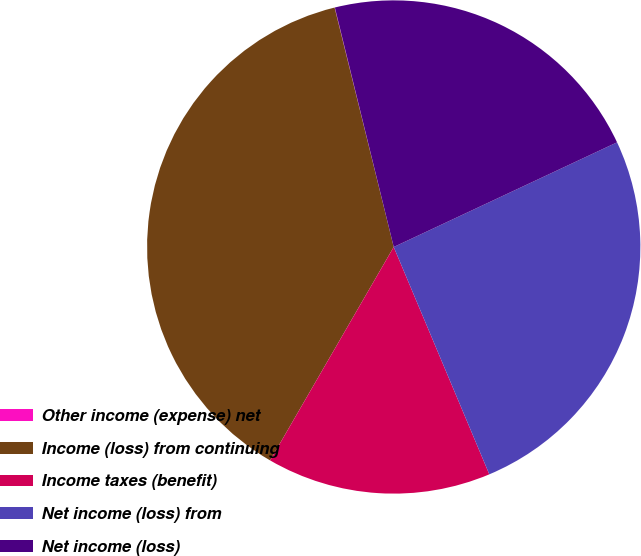<chart> <loc_0><loc_0><loc_500><loc_500><pie_chart><fcel>Other income (expense) net<fcel>Income (loss) from continuing<fcel>Income taxes (benefit)<fcel>Net income (loss) from<fcel>Net income (loss)<nl><fcel>0.02%<fcel>37.79%<fcel>14.69%<fcel>25.64%<fcel>21.86%<nl></chart> 